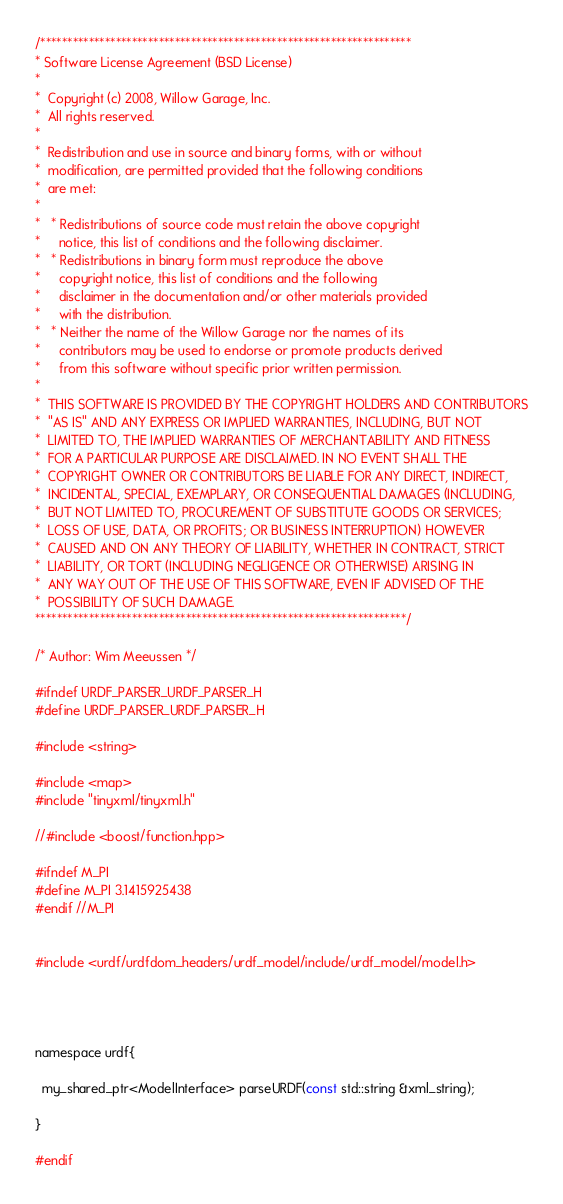<code> <loc_0><loc_0><loc_500><loc_500><_C_>/*********************************************************************
* Software License Agreement (BSD License)
* 
*  Copyright (c) 2008, Willow Garage, Inc.
*  All rights reserved.
* 
*  Redistribution and use in source and binary forms, with or without
*  modification, are permitted provided that the following conditions
*  are met:
* 
*   * Redistributions of source code must retain the above copyright
*     notice, this list of conditions and the following disclaimer.
*   * Redistributions in binary form must reproduce the above
*     copyright notice, this list of conditions and the following
*     disclaimer in the documentation and/or other materials provided
*     with the distribution.
*   * Neither the name of the Willow Garage nor the names of its
*     contributors may be used to endorse or promote products derived
*     from this software without specific prior written permission.
* 
*  THIS SOFTWARE IS PROVIDED BY THE COPYRIGHT HOLDERS AND CONTRIBUTORS
*  "AS IS" AND ANY EXPRESS OR IMPLIED WARRANTIES, INCLUDING, BUT NOT
*  LIMITED TO, THE IMPLIED WARRANTIES OF MERCHANTABILITY AND FITNESS
*  FOR A PARTICULAR PURPOSE ARE DISCLAIMED. IN NO EVENT SHALL THE
*  COPYRIGHT OWNER OR CONTRIBUTORS BE LIABLE FOR ANY DIRECT, INDIRECT,
*  INCIDENTAL, SPECIAL, EXEMPLARY, OR CONSEQUENTIAL DAMAGES (INCLUDING,
*  BUT NOT LIMITED TO, PROCUREMENT OF SUBSTITUTE GOODS OR SERVICES;
*  LOSS OF USE, DATA, OR PROFITS; OR BUSINESS INTERRUPTION) HOWEVER
*  CAUSED AND ON ANY THEORY OF LIABILITY, WHETHER IN CONTRACT, STRICT
*  LIABILITY, OR TORT (INCLUDING NEGLIGENCE OR OTHERWISE) ARISING IN
*  ANY WAY OUT OF THE USE OF THIS SOFTWARE, EVEN IF ADVISED OF THE
*  POSSIBILITY OF SUCH DAMAGE.
*********************************************************************/

/* Author: Wim Meeussen */

#ifndef URDF_PARSER_URDF_PARSER_H
#define URDF_PARSER_URDF_PARSER_H

#include <string>

#include <map>
#include "tinyxml/tinyxml.h"

//#include <boost/function.hpp>

#ifndef M_PI
#define M_PI 3.1415925438
#endif //M_PI


#include <urdf/urdfdom_headers/urdf_model/include/urdf_model/model.h>




namespace urdf{

  my_shared_ptr<ModelInterface> parseURDF(const std::string &xml_string);

}

#endif
</code> 